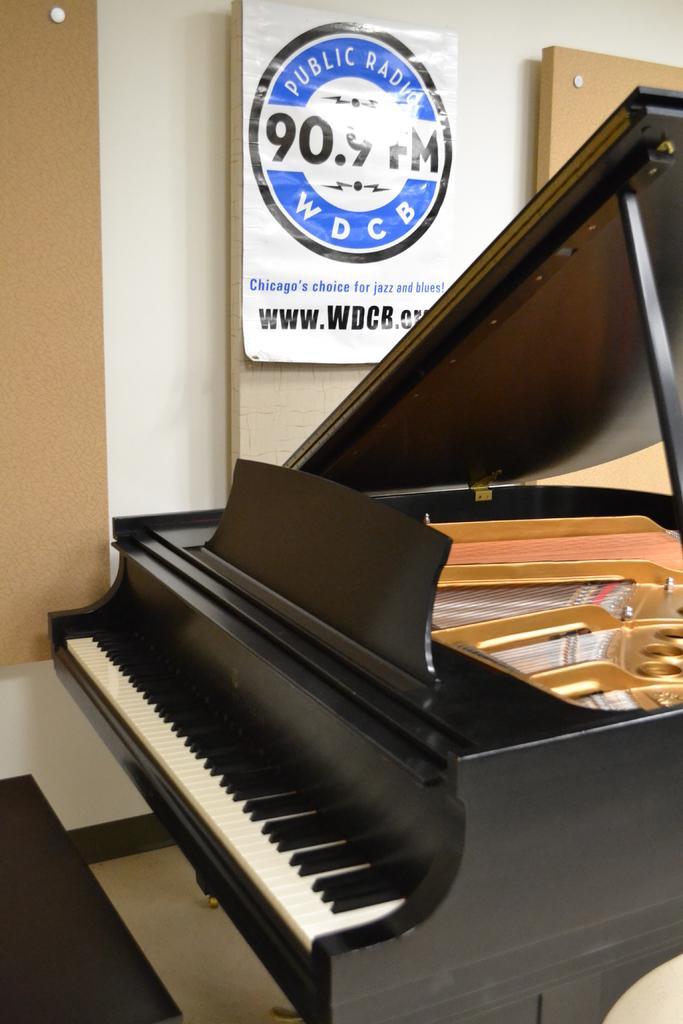In one or two sentences, can you explain what this image depicts? A poster is on wall. Here we can able to see a piano keyboard which is in black color. The keys are in black and white color. 